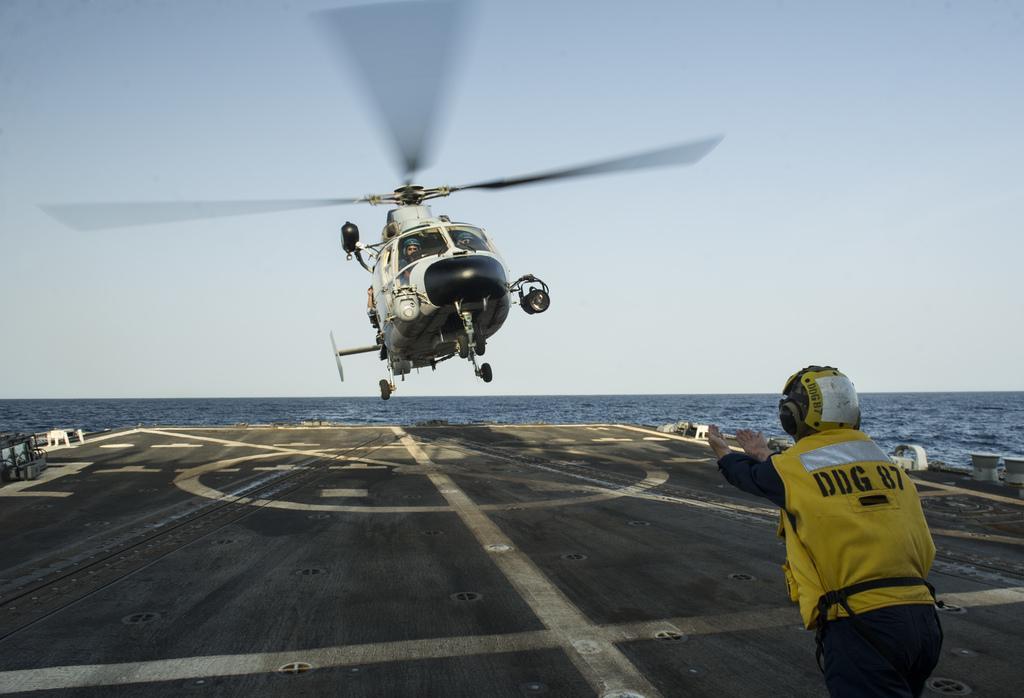Can you describe this image briefly? In this image I can see aeroplane which is in white and black color. In front I can see a person wearing yellow and black dress. Back I can see a water. The sky is in blue and white color. 